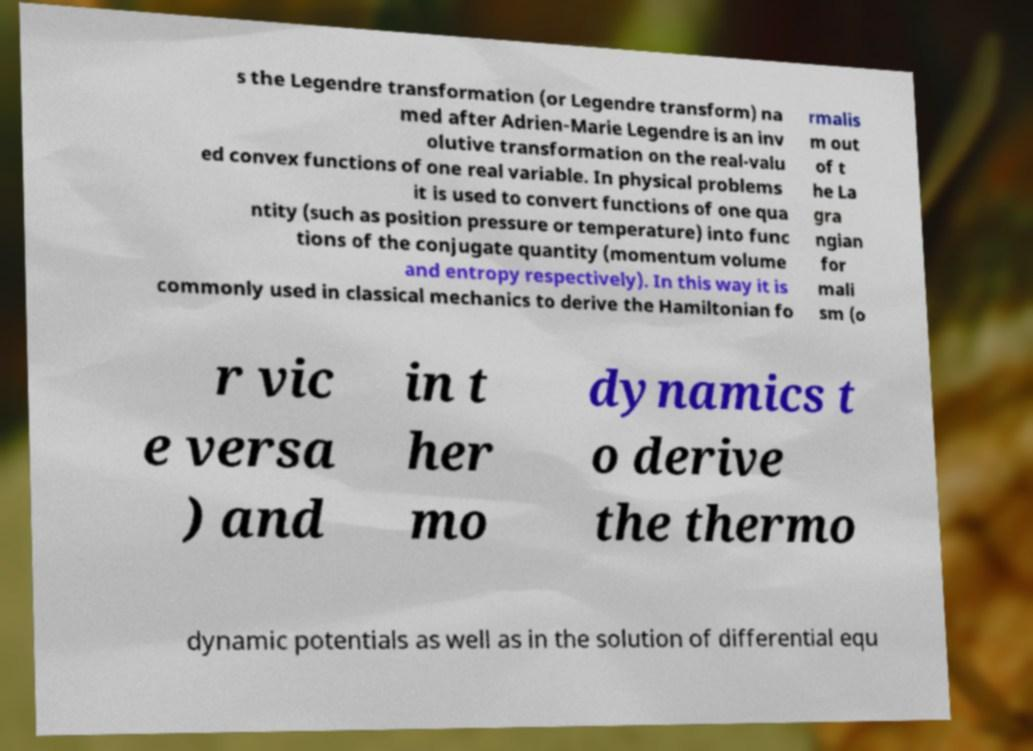Please read and relay the text visible in this image. What does it say? s the Legendre transformation (or Legendre transform) na med after Adrien-Marie Legendre is an inv olutive transformation on the real-valu ed convex functions of one real variable. In physical problems it is used to convert functions of one qua ntity (such as position pressure or temperature) into func tions of the conjugate quantity (momentum volume and entropy respectively). In this way it is commonly used in classical mechanics to derive the Hamiltonian fo rmalis m out of t he La gra ngian for mali sm (o r vic e versa ) and in t her mo dynamics t o derive the thermo dynamic potentials as well as in the solution of differential equ 